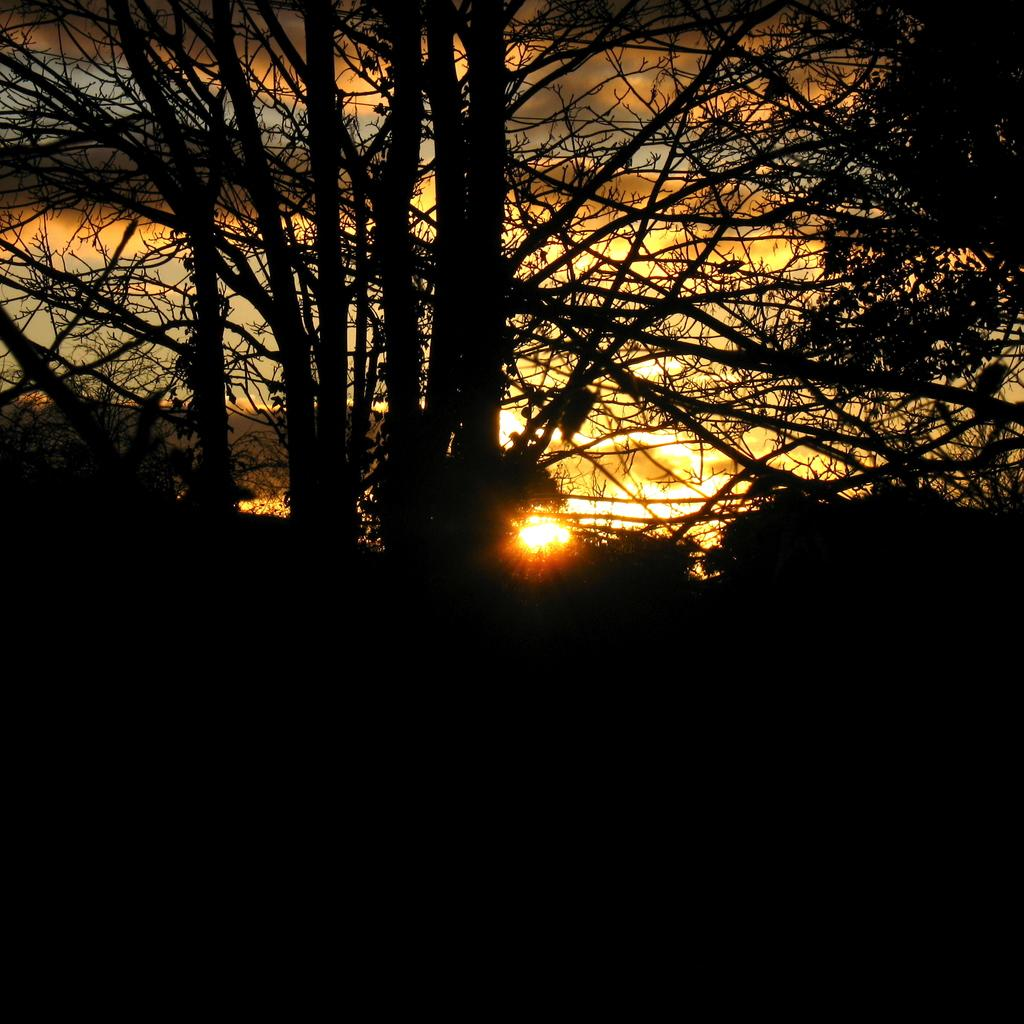What type of vegetation can be seen in the image? There are trees in the image. What celestial body is visible in the background of the image? The sun is visible in the background of the image. What else can be seen in the background of the image? There is sky visible in the background of the image. What is the condition of the sky in the image? Clouds are present in the sky. Can you tell me how many attempts the owl made to swallow the throat in the image? There is no owl or throat present in the image, so this question cannot be answered. 